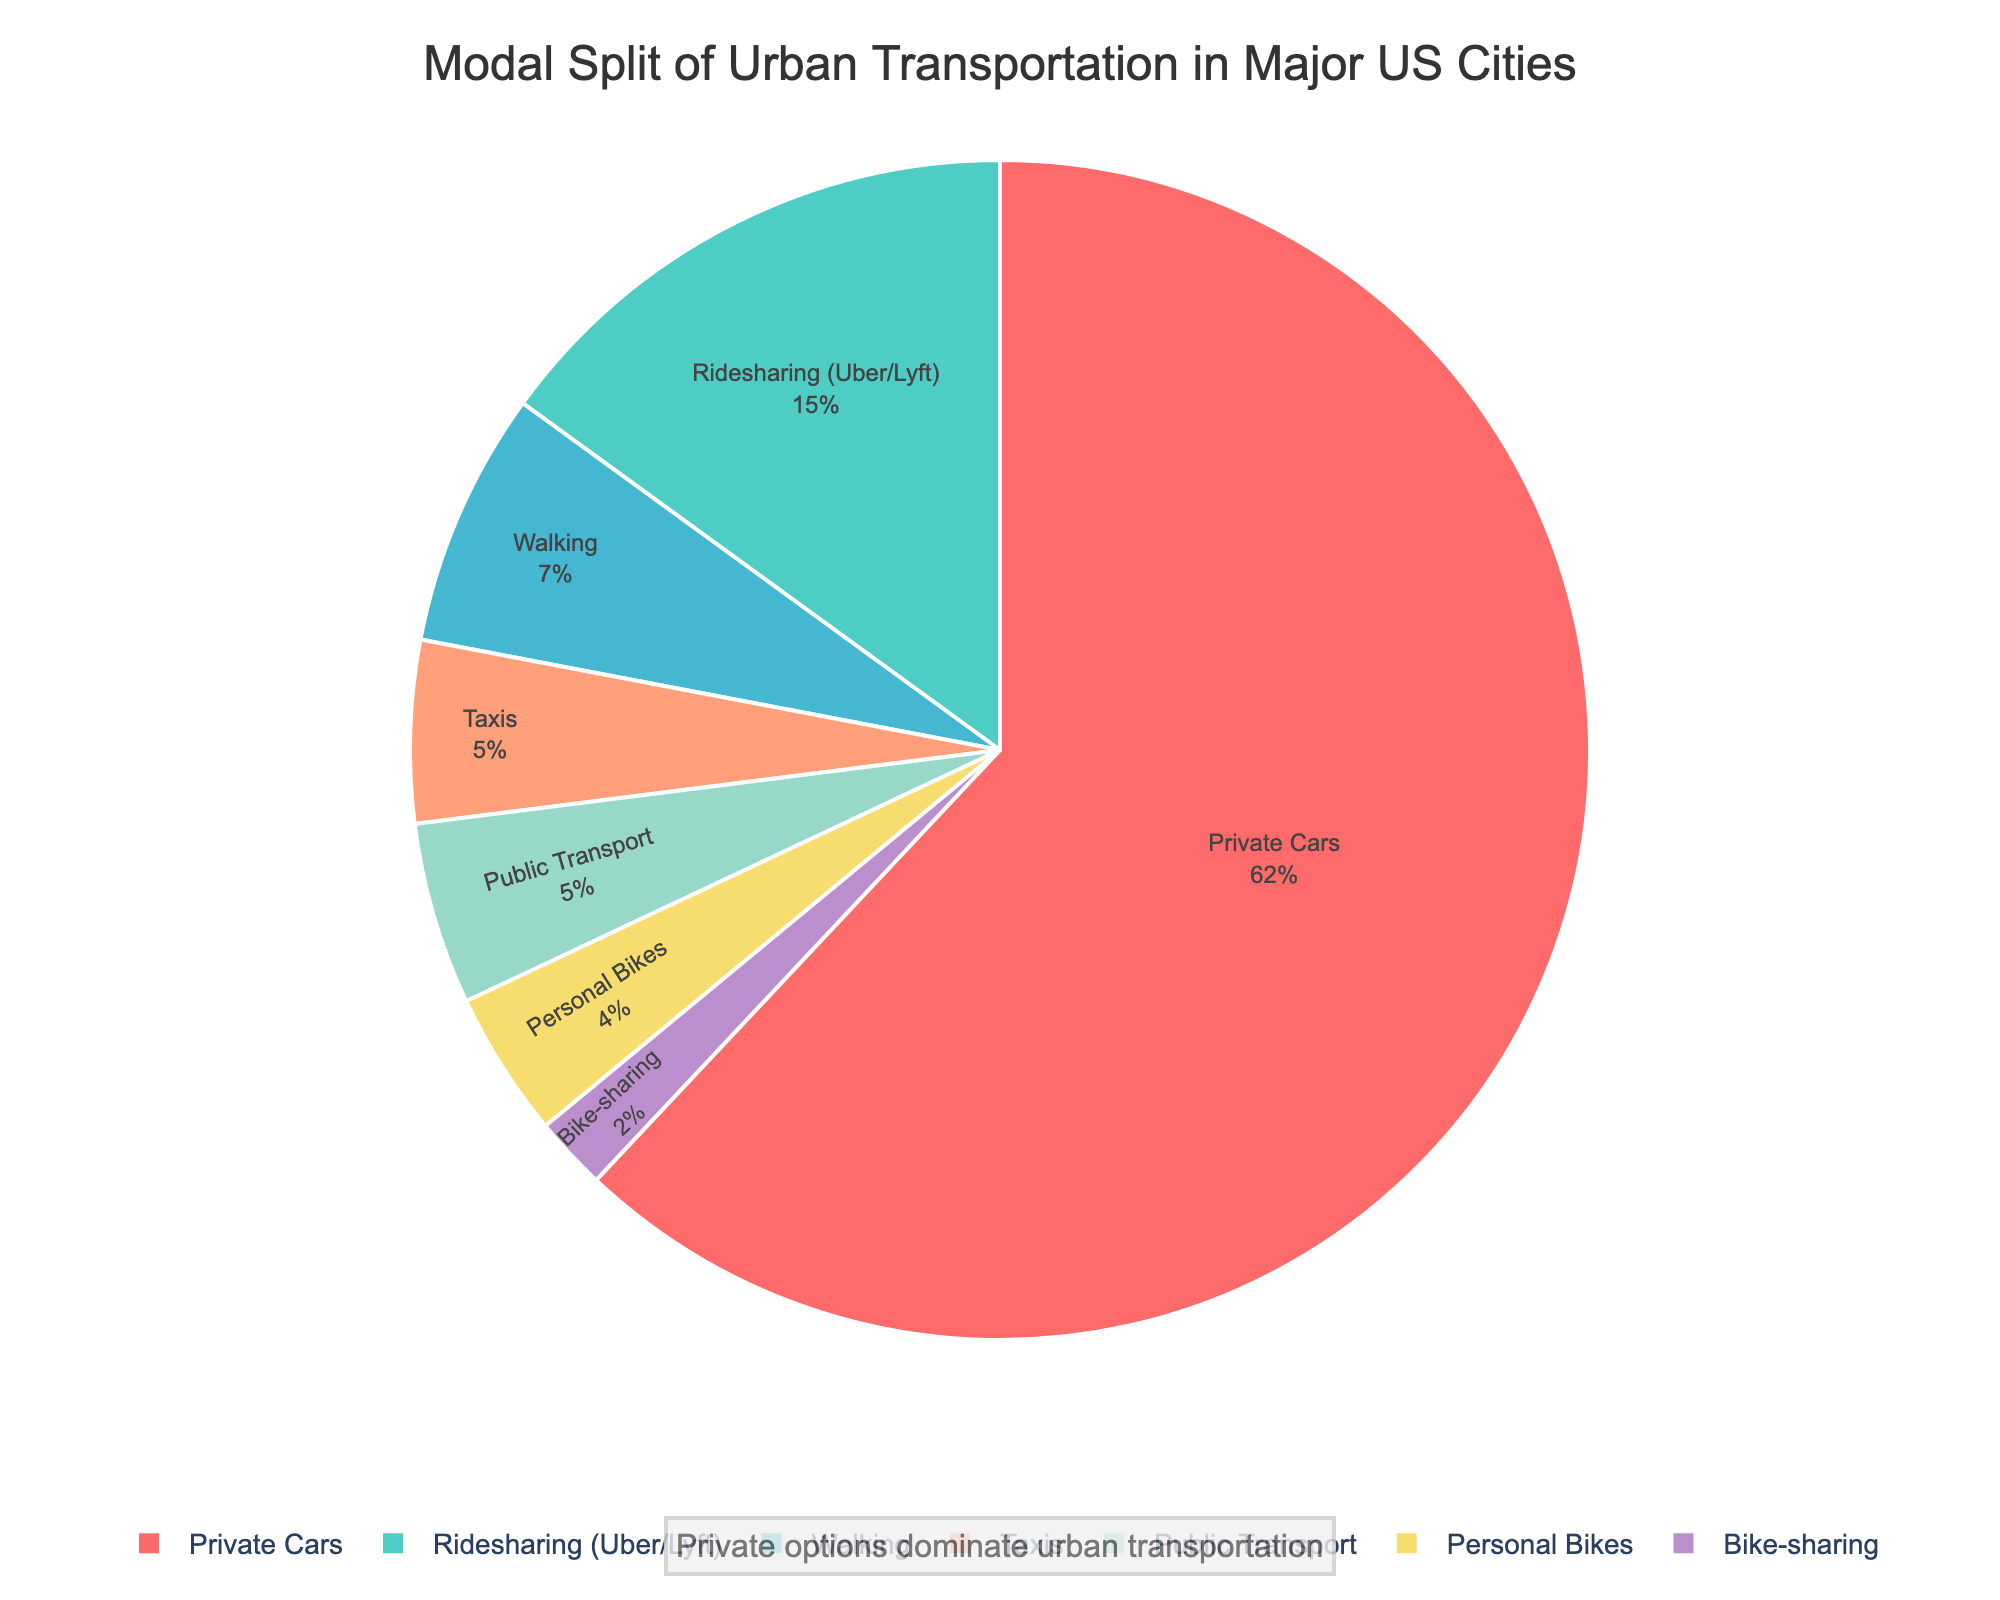What percentage of urban transportation in major US cities is covered by private options altogether? To determine the total percentage for private options, sum up the percentages for Private Cars, Ridesharing (Uber/Lyft), Taxis, and Personal Bikes. This is 62% + 15% + 5% + 4% = 86%.
Answer: 86% How does the combined percentage of bike options (Personal Bikes and Bike-sharing) compare to walking? The combined percentage for bike options is 4% + 2% = 6%. Walking is at 7%. Therefore, walking is 1% higher than the combined bike options.
Answer: 1% By what factor is the percentage of Private Cars greater than that of Public Buses? The percentage of Private Cars is 62% while Public Buses account for 3%. The factor is calculated by dividing the percentage of Private Cars by that of Public Buses: 62% / 3% ≈ 20.67.
Answer: 20.67 Which mode of transportation has the smallest percentage share, and what is its value? By observing the pie chart, the mode with the smallest slice is Light Rail, which has a 1% share.
Answer: Light Rail, 1% How does the combined percentage of public transport options (Public Buses, Subway/Metro, and Light Rail) compare to Ridesharing (Uber/Lyft)? The combined percentage for public transport options is 3% + 1% + 1% = 5%. Ridesharing (Uber/Lyft) is at 15%. Thus, ridesharing is 10% higher than public transport options combined.
Answer: 10% What colors are used to represent the mode with the highest percentage and the mode with the smallest percentage in the pie chart? The mode with the highest percentage (Private Cars, 62%) is represented in red. The mode with the smallest percentage (Light Rail, 1%) is represented in blue.
Answer: Red and Blue What percentage of urban transportation is covered by all non-public transport modes combined? Adding up all non-public transport modes: Private Cars (62%), Ridesharing (Uber/Lyft) (15%), Taxis (5%), Personal Bikes (4%), Bike-sharing (2%), and Walking (7%), we get 62% + 15% + 5% + 4% + 2% + 7% = 95%.
Answer: 95% Compare the share of Walking to the combined share of Public Buses and Bike-sharing. The percentage for Walking is 7%. The combined share for Public Buses (3%) and Bike-sharing (2%) is 3% + 2% = 5%. Walking has a 2% higher share than these combined options.
Answer: 2% 